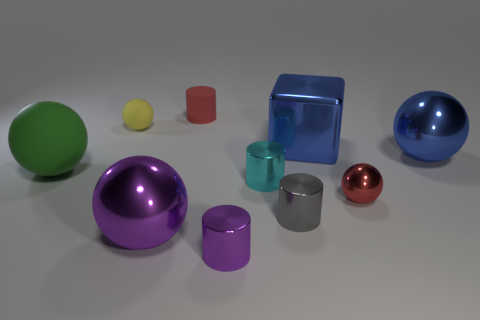What material do the objects appear to be made from? The objects exhibit various reflective and refractive qualities suggesting they are made from materials like glass and polished metal.  Are there any patterns or themes you can deduce from this array of objects? The objects seem to represent a study in geometric shapes and colors, possibly exploring concepts of light, reflection, and refraction with an artistic or educational intent. 